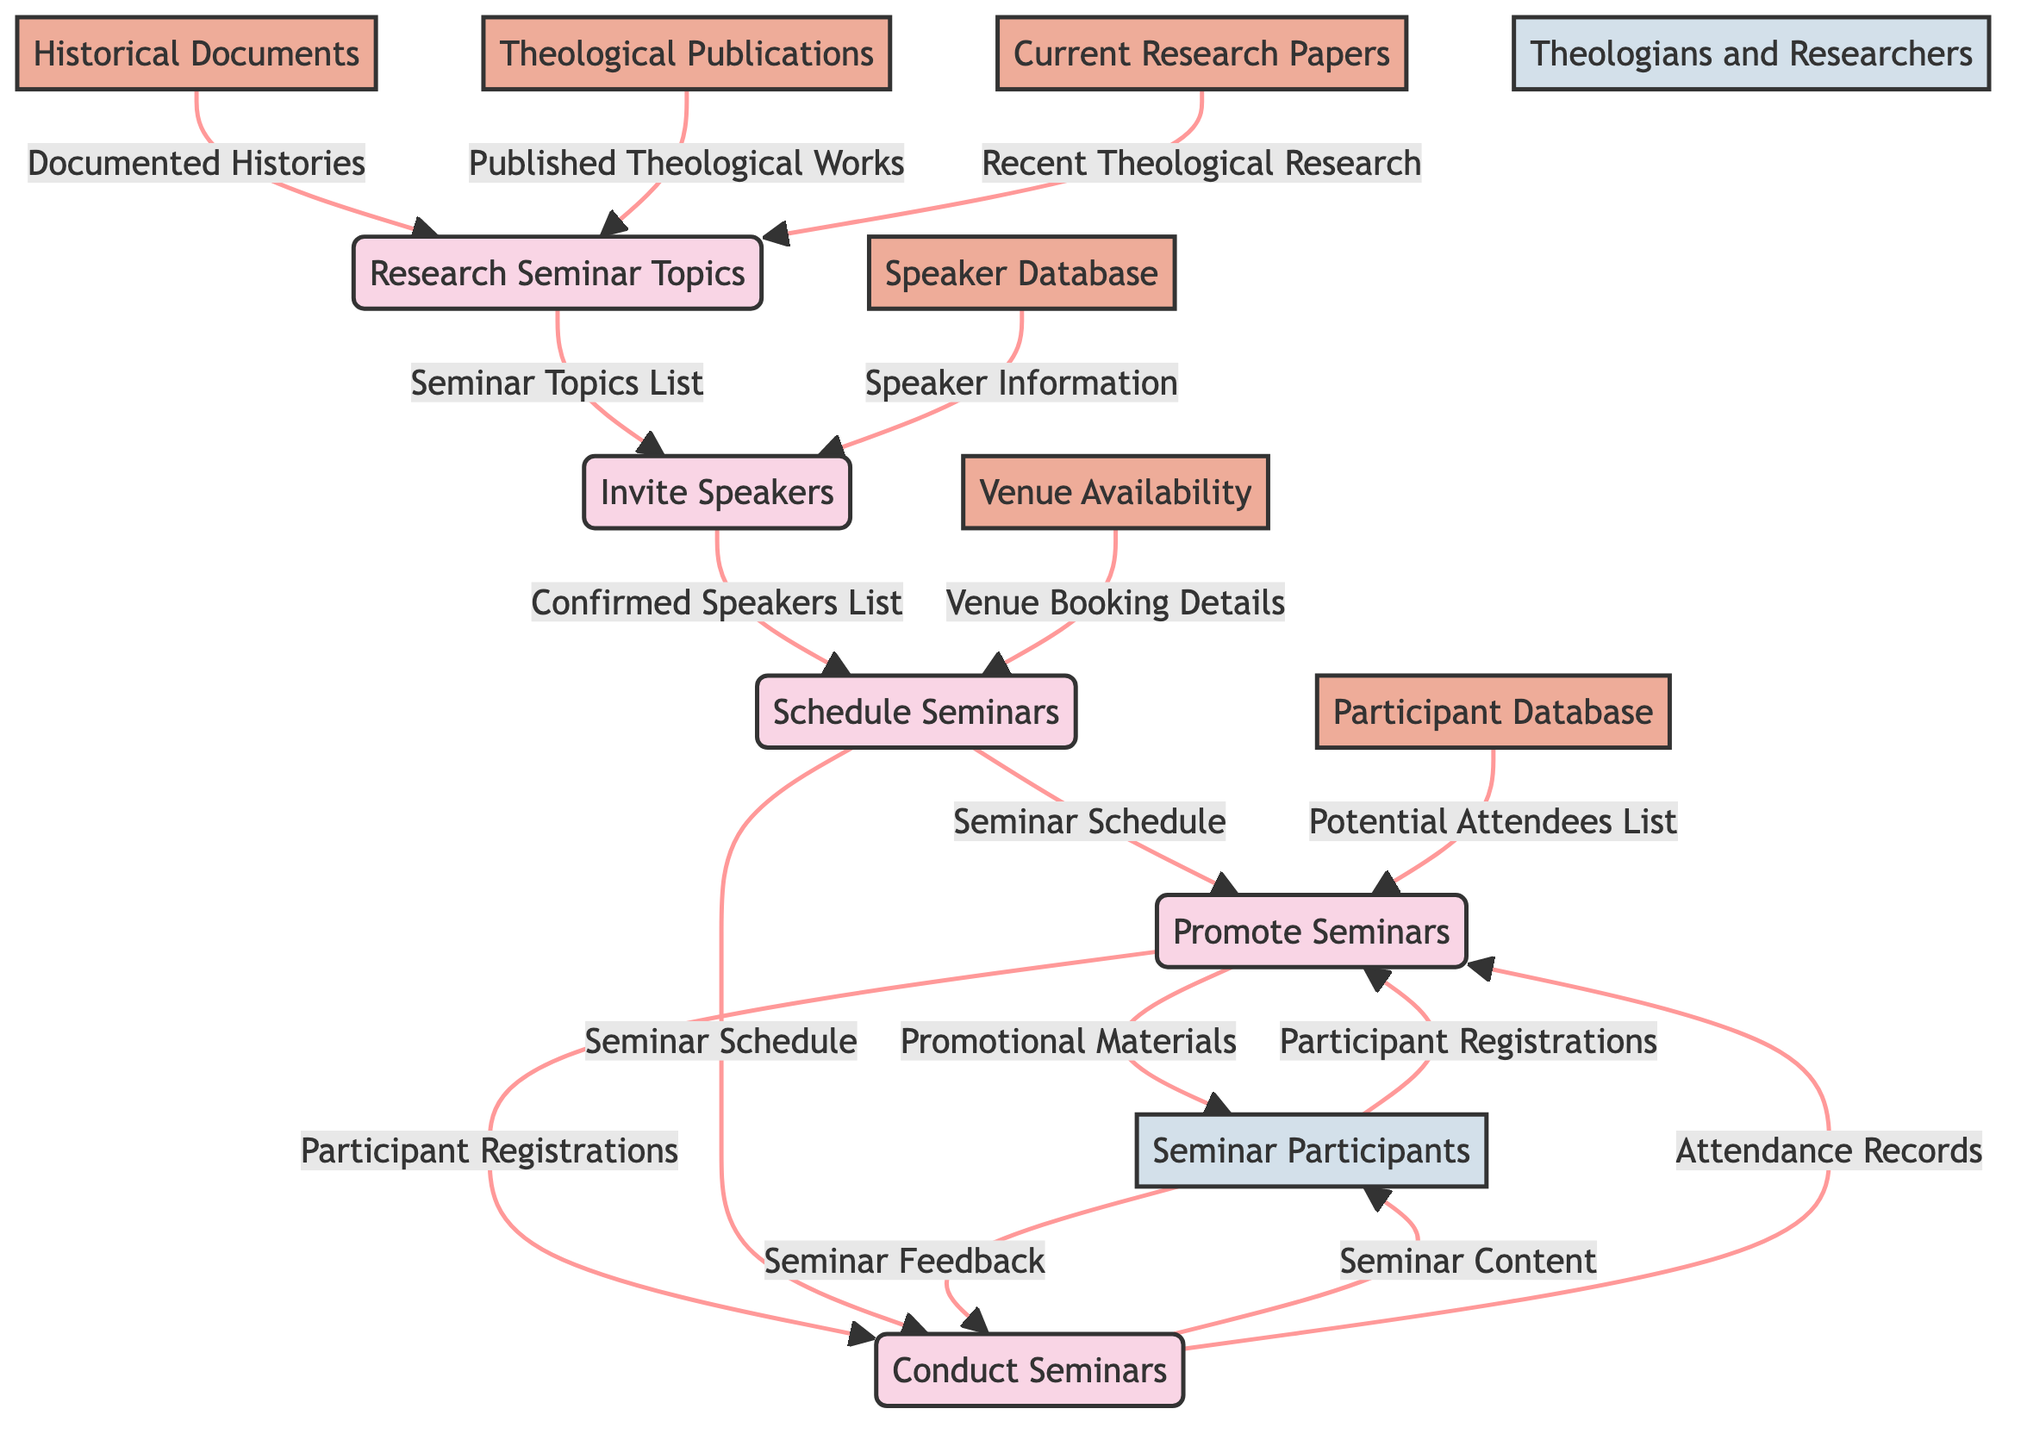What is the first process in the seminar series planning? The first process listed in the diagram is "Research Seminar Topics." This process identifies and categorizes seminar topics based on various inputs.
Answer: Research Seminar Topics How many data stores are present in the diagram? The diagram lists six data stores: Historical Documents, Theological Publications, Current Research Papers, Speaker Database, Venue Availability, and Participant Database. By counting these, we find a total of six data stores.
Answer: 6 Which process outputs the "Confirmed Speakers List"? The "Invite Speakers" process takes inputs such as the Seminar Topics List and Speaker Database, and it outputs the "Confirmed Speakers List."
Answer: Invite Speakers What information does the "Promote Seminars" process receive from the "Schedule Seminars"? The "Promote Seminars" process receives the "Seminar Schedule" from the "Schedule Seminars" process. This schedule is essential for advertising the seminars.
Answer: Seminar Schedule How does the "Conduct Seminars" process receive attendance information? The "Conduct Seminars" process receives attendance information through "Participant Registrations," which are sent from the "Promote Seminars" process. Additionally, it gathers "Seminar Feedback" from the seminar participants during the conducted seminars.
Answer: Participant Registrations Which external entity is involved in inviting speakers? The external entity involved in inviting speakers is "Theologians and Researchers." This entity represents the experts that may be contacted for speaking opportunities in the seminar series.
Answer: Theologians and Researchers From which data store does the "Research Seminar Topics" process gather its inputs? The "Research Seminar Topics" process gathers inputs from three data stores: Historical Documents, Theological Publications, and Current Research Papers, all of which provide necessary background to identify seminar topics.
Answer: Historical Documents, Theological Publications, Current Research Papers What type of materials does the "Promote Seminars" process produce? The "Promote Seminars" process produces "Promotional Materials" that are used to attract participants to the seminar series, in addition to managing registrations.
Answer: Promotional Materials Explain the flow of information from "Participants" to "Conduct Seminars." The flow begins with "Participants" providing "Seminar Feedback" which is sent to the "Conduct Seminars" process. In addition, "Conduct Seminars" sends "Seminar Content" to the "Seminar Participants," establishing a two-way communication regarding feedback and content delivery.
Answer: Seminar Feedback, Seminar Content 